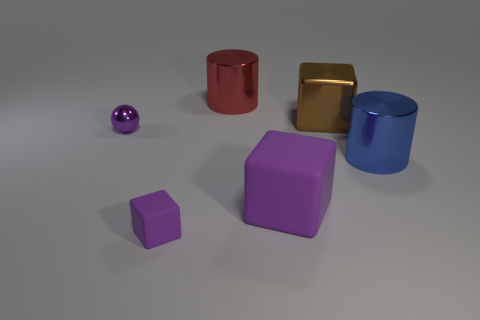What is the material of the tiny object that is in front of the large cylinder that is to the right of the red object?
Keep it short and to the point. Rubber. There is a brown object that is the same shape as the big purple rubber object; what size is it?
Keep it short and to the point. Large. Is the color of the shiny ball that is behind the large matte thing the same as the tiny cube?
Offer a terse response. Yes. Is the number of red metallic things less than the number of big cyan spheres?
Provide a short and direct response. No. What number of other objects are the same color as the large rubber object?
Give a very brief answer. 2. Is the tiny purple thing that is in front of the small purple ball made of the same material as the brown cube?
Keep it short and to the point. No. What material is the cube that is to the left of the red thing?
Offer a very short reply. Rubber. What is the size of the metallic object that is in front of the shiny object that is on the left side of the red cylinder?
Make the answer very short. Large. Are there any tiny things that have the same material as the big brown object?
Provide a succinct answer. Yes. The small purple thing that is behind the large cylinder that is in front of the tiny purple object to the left of the tiny matte cube is what shape?
Offer a very short reply. Sphere. 